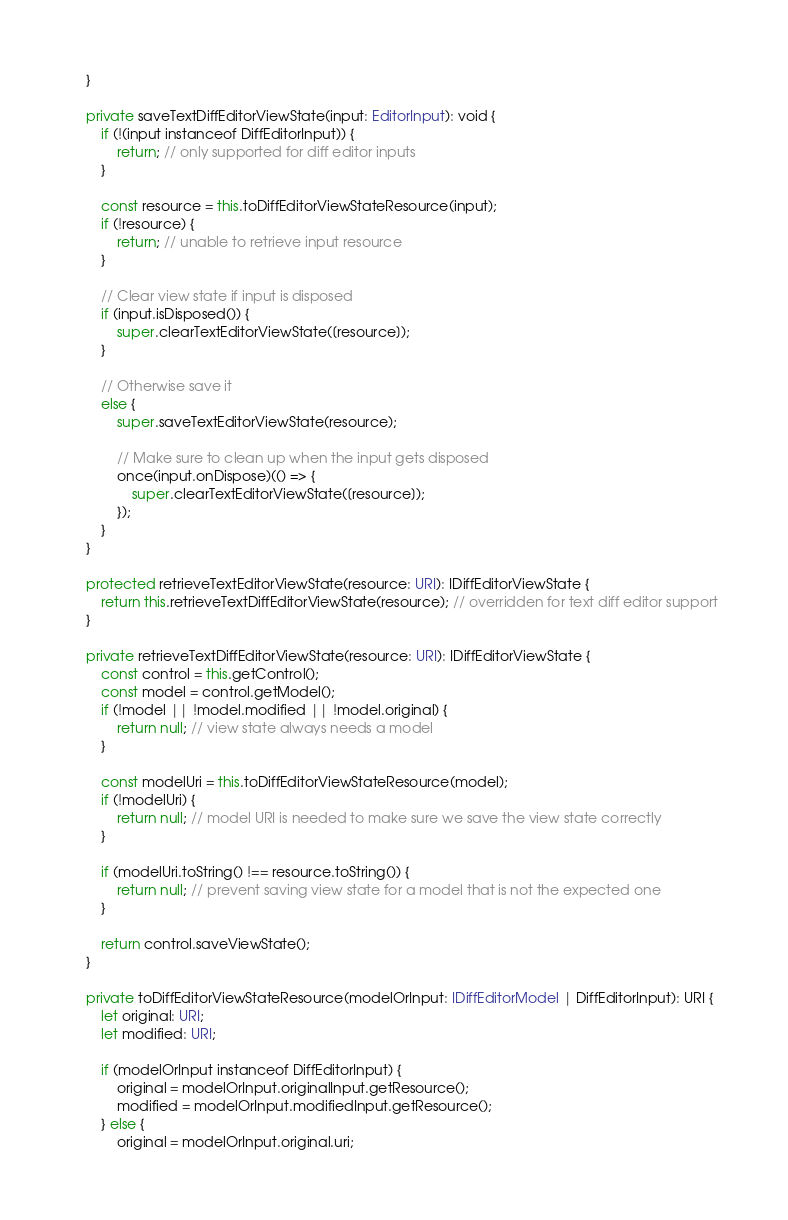<code> <loc_0><loc_0><loc_500><loc_500><_TypeScript_>	}

	private saveTextDiffEditorViewState(input: EditorInput): void {
		if (!(input instanceof DiffEditorInput)) {
			return; // only supported for diff editor inputs
		}

		const resource = this.toDiffEditorViewStateResource(input);
		if (!resource) {
			return; // unable to retrieve input resource
		}

		// Clear view state if input is disposed
		if (input.isDisposed()) {
			super.clearTextEditorViewState([resource]);
		}

		// Otherwise save it
		else {
			super.saveTextEditorViewState(resource);

			// Make sure to clean up when the input gets disposed
			once(input.onDispose)(() => {
				super.clearTextEditorViewState([resource]);
			});
		}
	}

	protected retrieveTextEditorViewState(resource: URI): IDiffEditorViewState {
		return this.retrieveTextDiffEditorViewState(resource); // overridden for text diff editor support
	}

	private retrieveTextDiffEditorViewState(resource: URI): IDiffEditorViewState {
		const control = this.getControl();
		const model = control.getModel();
		if (!model || !model.modified || !model.original) {
			return null; // view state always needs a model
		}

		const modelUri = this.toDiffEditorViewStateResource(model);
		if (!modelUri) {
			return null; // model URI is needed to make sure we save the view state correctly
		}

		if (modelUri.toString() !== resource.toString()) {
			return null; // prevent saving view state for a model that is not the expected one
		}

		return control.saveViewState();
	}

	private toDiffEditorViewStateResource(modelOrInput: IDiffEditorModel | DiffEditorInput): URI {
		let original: URI;
		let modified: URI;

		if (modelOrInput instanceof DiffEditorInput) {
			original = modelOrInput.originalInput.getResource();
			modified = modelOrInput.modifiedInput.getResource();
		} else {
			original = modelOrInput.original.uri;</code> 